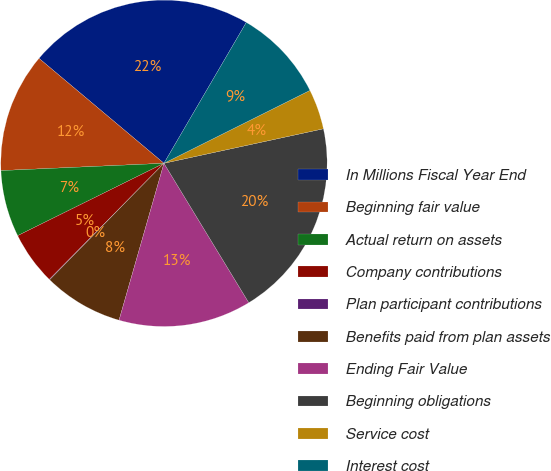Convert chart to OTSL. <chart><loc_0><loc_0><loc_500><loc_500><pie_chart><fcel>In Millions Fiscal Year End<fcel>Beginning fair value<fcel>Actual return on assets<fcel>Company contributions<fcel>Plan participant contributions<fcel>Benefits paid from plan assets<fcel>Ending Fair Value<fcel>Beginning obligations<fcel>Service cost<fcel>Interest cost<nl><fcel>22.3%<fcel>11.83%<fcel>6.6%<fcel>5.29%<fcel>0.05%<fcel>7.91%<fcel>13.14%<fcel>19.69%<fcel>3.98%<fcel>9.21%<nl></chart> 